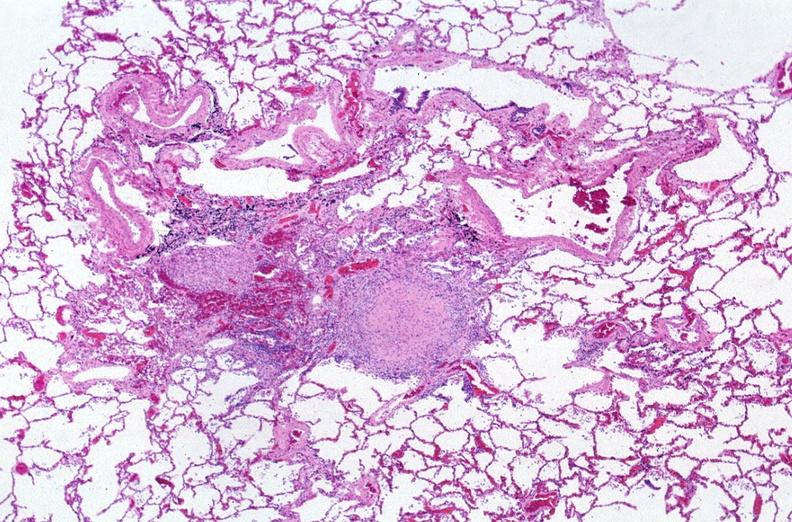where is this?
Answer the question using a single word or phrase. Lung 